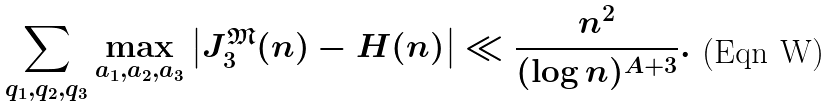<formula> <loc_0><loc_0><loc_500><loc_500>\sum _ { q _ { 1 } , q _ { 2 } , q _ { 3 } } \max _ { a _ { 1 } , a _ { 2 } , a _ { 3 } } \left | J _ { 3 } ^ { \mathfrak { M } } ( n ) - H ( n ) \right | \ll \frac { n ^ { 2 } } { ( \log n ) ^ { A + 3 } } .</formula> 